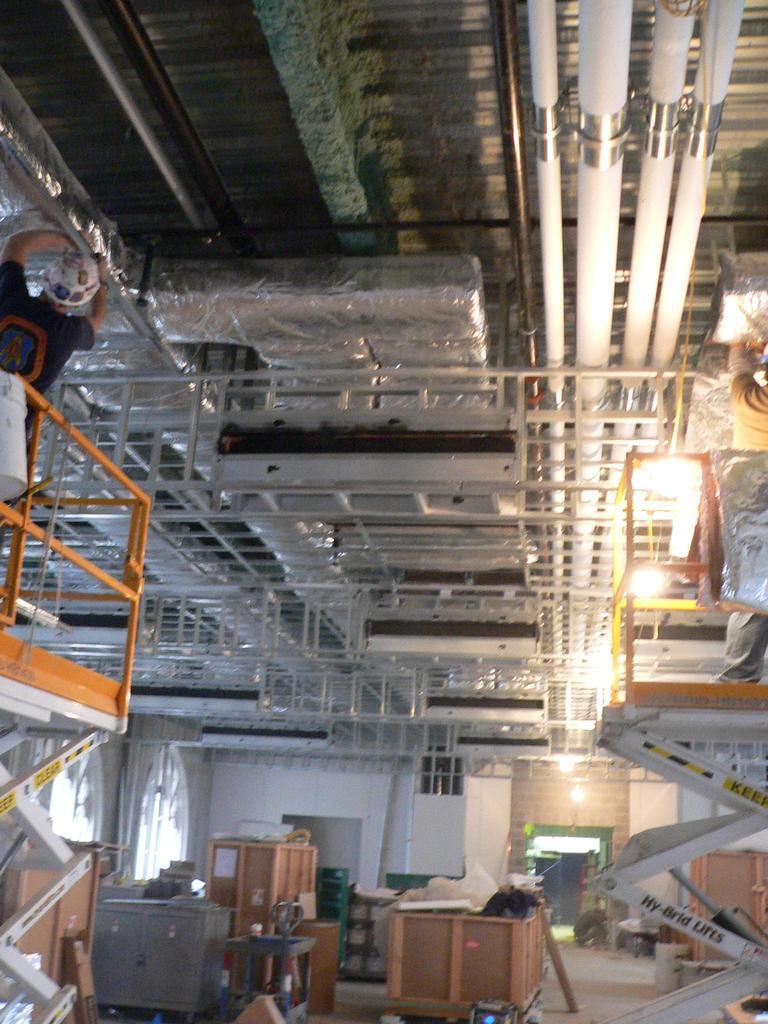Can you describe this image briefly? Here in this picture in the front, on the left side we can see a person standing on an hydraulic lift and he is repairing something on the roof and we can see he is wearing helmet and we can see pores present on the roof and on the floor we can see some wooden boxes present and on the right side also we can see other person standing on the hydraulic lift and we can see lights also present. 